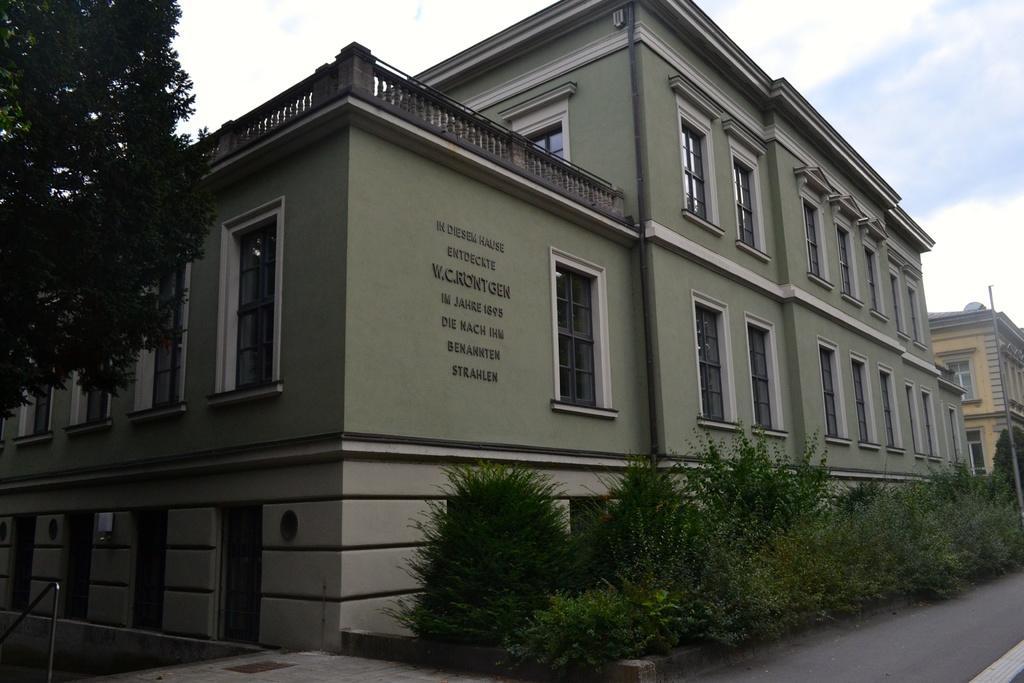Describe this image in one or two sentences. In this image there is the sky towards the top of the image, there are clouds in the sky, there are buildings, there is text on the buildings, there are windows, there is a pole towards the right of the image, there are plants towards the right of the image, there is a tree towards the left of the image, there is road towards the bottom of the image, there is an object towards the bottom of the image. 